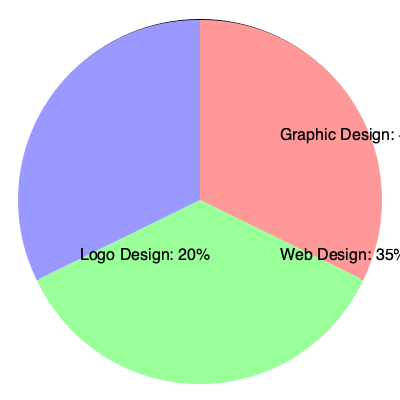As a freelance graphic designer, your annual net income from self-employment is $80,000, distributed as shown in the pie chart. If the self-employment tax rate is 15.3%, with 12.4% for Social Security (capped at $142,800) and 2.9% for Medicare (uncapped), calculate your total self-employment tax for the year. To calculate the self-employment tax:

1. Determine the taxable income:
   - Total net income: $80,000
   - This is below the Social Security cap, so all income is subject to both parts of the tax

2. Calculate Social Security tax:
   $80,000 \times 12.4\% = $9,920

3. Calculate Medicare tax:
   $80,000 \times 2.9\% = $2,320

4. Sum up the total self-employment tax:
   $9,920 + $2,320 = $12,240

5. Apply the deduction for employer-equivalent portion:
   $12,240 \times 50\% = $6,120

6. Calculate the final self-employment tax:
   $12,240 - $6,120 = $6,120

The total self-employment tax is $6,120.

Note: The pie chart distribution of income sources doesn't affect the calculation in this case, as all income is below the Social Security cap. However, it's important for freelancers to track income sources for other tax and business purposes.
Answer: $6,120 